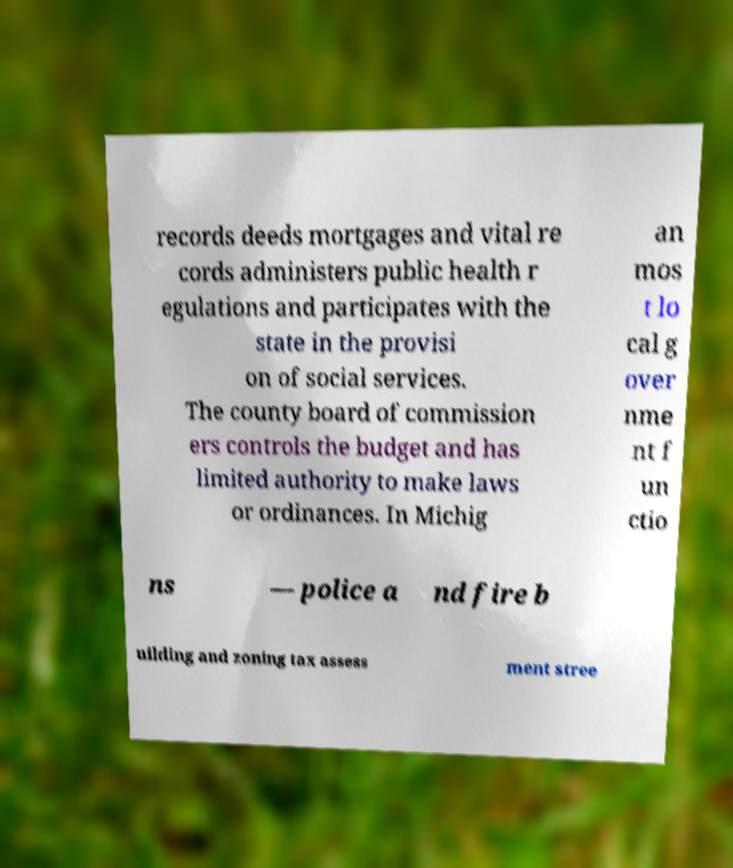I need the written content from this picture converted into text. Can you do that? records deeds mortgages and vital re cords administers public health r egulations and participates with the state in the provisi on of social services. The county board of commission ers controls the budget and has limited authority to make laws or ordinances. In Michig an mos t lo cal g over nme nt f un ctio ns — police a nd fire b uilding and zoning tax assess ment stree 